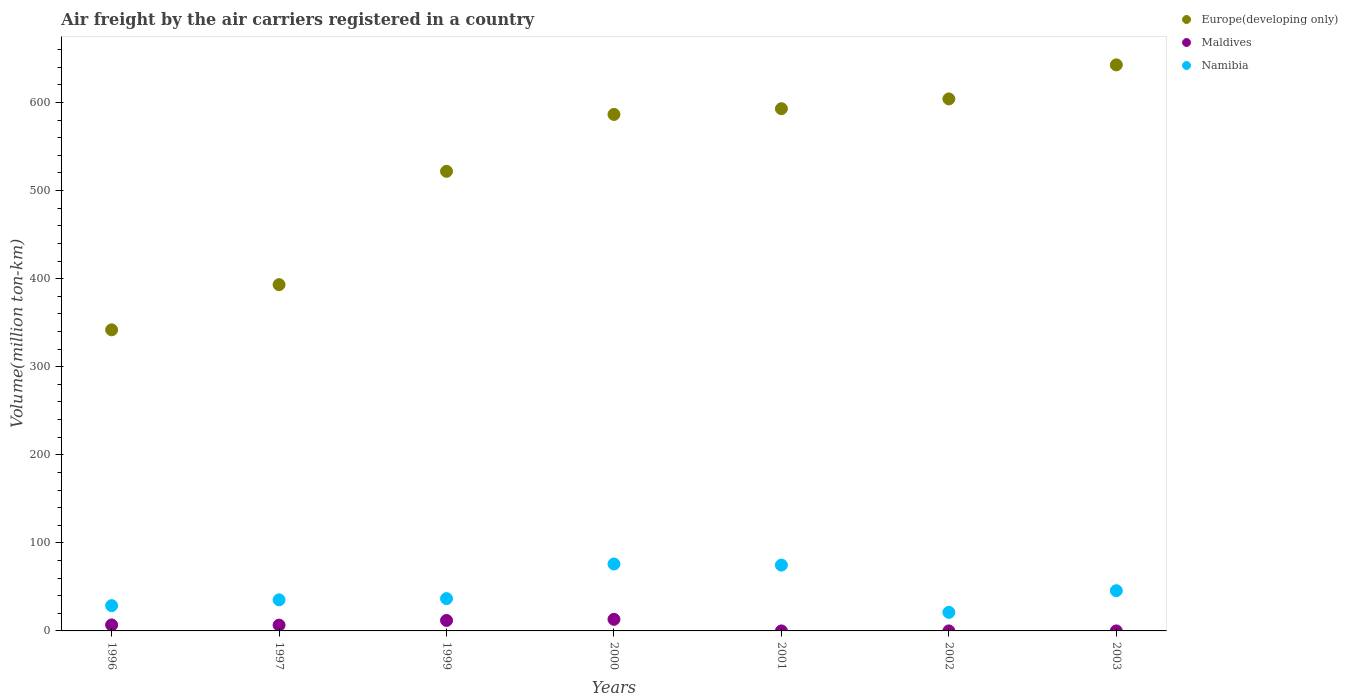How many different coloured dotlines are there?
Provide a short and direct response. 3. What is the volume of the air carriers in Namibia in 2000?
Offer a very short reply. 76.01. Across all years, what is the maximum volume of the air carriers in Maldives?
Your answer should be very brief. 13.17. Across all years, what is the minimum volume of the air carriers in Maldives?
Your answer should be compact. 0.01. What is the total volume of the air carriers in Namibia in the graph?
Ensure brevity in your answer.  318.19. What is the difference between the volume of the air carriers in Maldives in 2000 and that in 2002?
Provide a short and direct response. 13.16. What is the difference between the volume of the air carriers in Maldives in 2003 and the volume of the air carriers in Namibia in 1996?
Offer a very short reply. -28.69. What is the average volume of the air carriers in Namibia per year?
Give a very brief answer. 45.46. In the year 1999, what is the difference between the volume of the air carriers in Namibia and volume of the air carriers in Europe(developing only)?
Offer a terse response. -485.2. In how many years, is the volume of the air carriers in Maldives greater than 200 million ton-km?
Keep it short and to the point. 0. What is the ratio of the volume of the air carriers in Maldives in 1997 to that in 1999?
Your response must be concise. 0.55. What is the difference between the highest and the second highest volume of the air carriers in Namibia?
Ensure brevity in your answer.  1.26. What is the difference between the highest and the lowest volume of the air carriers in Maldives?
Keep it short and to the point. 13.16. In how many years, is the volume of the air carriers in Namibia greater than the average volume of the air carriers in Namibia taken over all years?
Offer a terse response. 3. Is the sum of the volume of the air carriers in Namibia in 2001 and 2002 greater than the maximum volume of the air carriers in Europe(developing only) across all years?
Your answer should be very brief. No. Is it the case that in every year, the sum of the volume of the air carriers in Europe(developing only) and volume of the air carriers in Maldives  is greater than the volume of the air carriers in Namibia?
Your response must be concise. Yes. Is the volume of the air carriers in Maldives strictly less than the volume of the air carriers in Europe(developing only) over the years?
Offer a terse response. Yes. How many years are there in the graph?
Ensure brevity in your answer.  7. Are the values on the major ticks of Y-axis written in scientific E-notation?
Your answer should be very brief. No. How are the legend labels stacked?
Your answer should be very brief. Vertical. What is the title of the graph?
Provide a short and direct response. Air freight by the air carriers registered in a country. Does "Estonia" appear as one of the legend labels in the graph?
Keep it short and to the point. No. What is the label or title of the X-axis?
Offer a terse response. Years. What is the label or title of the Y-axis?
Keep it short and to the point. Volume(million ton-km). What is the Volume(million ton-km) of Europe(developing only) in 1996?
Provide a succinct answer. 341.9. What is the Volume(million ton-km) of Maldives in 1996?
Offer a terse response. 6.8. What is the Volume(million ton-km) of Namibia in 1996?
Your answer should be very brief. 28.7. What is the Volume(million ton-km) of Europe(developing only) in 1997?
Give a very brief answer. 393.2. What is the Volume(million ton-km) of Maldives in 1997?
Keep it short and to the point. 6.6. What is the Volume(million ton-km) in Namibia in 1997?
Offer a very short reply. 35.3. What is the Volume(million ton-km) in Europe(developing only) in 1999?
Your answer should be compact. 521.9. What is the Volume(million ton-km) of Maldives in 1999?
Make the answer very short. 11.9. What is the Volume(million ton-km) of Namibia in 1999?
Make the answer very short. 36.7. What is the Volume(million ton-km) in Europe(developing only) in 2000?
Make the answer very short. 586.49. What is the Volume(million ton-km) in Maldives in 2000?
Provide a succinct answer. 13.17. What is the Volume(million ton-km) of Namibia in 2000?
Your answer should be very brief. 76.01. What is the Volume(million ton-km) in Europe(developing only) in 2001?
Ensure brevity in your answer.  593. What is the Volume(million ton-km) of Maldives in 2001?
Make the answer very short. 0.01. What is the Volume(million ton-km) in Namibia in 2001?
Offer a very short reply. 74.74. What is the Volume(million ton-km) of Europe(developing only) in 2002?
Make the answer very short. 604.13. What is the Volume(million ton-km) in Maldives in 2002?
Your answer should be compact. 0.01. What is the Volume(million ton-km) of Namibia in 2002?
Your answer should be compact. 21.06. What is the Volume(million ton-km) in Europe(developing only) in 2003?
Make the answer very short. 642.76. What is the Volume(million ton-km) in Maldives in 2003?
Your answer should be very brief. 0.01. What is the Volume(million ton-km) of Namibia in 2003?
Ensure brevity in your answer.  45.67. Across all years, what is the maximum Volume(million ton-km) of Europe(developing only)?
Give a very brief answer. 642.76. Across all years, what is the maximum Volume(million ton-km) in Maldives?
Your answer should be very brief. 13.17. Across all years, what is the maximum Volume(million ton-km) in Namibia?
Provide a succinct answer. 76.01. Across all years, what is the minimum Volume(million ton-km) in Europe(developing only)?
Ensure brevity in your answer.  341.9. Across all years, what is the minimum Volume(million ton-km) of Maldives?
Your response must be concise. 0.01. Across all years, what is the minimum Volume(million ton-km) in Namibia?
Offer a terse response. 21.06. What is the total Volume(million ton-km) in Europe(developing only) in the graph?
Your answer should be compact. 3683.38. What is the total Volume(million ton-km) in Maldives in the graph?
Offer a very short reply. 38.5. What is the total Volume(million ton-km) in Namibia in the graph?
Your answer should be compact. 318.19. What is the difference between the Volume(million ton-km) in Europe(developing only) in 1996 and that in 1997?
Your answer should be very brief. -51.3. What is the difference between the Volume(million ton-km) of Namibia in 1996 and that in 1997?
Provide a short and direct response. -6.6. What is the difference between the Volume(million ton-km) of Europe(developing only) in 1996 and that in 1999?
Make the answer very short. -180. What is the difference between the Volume(million ton-km) of Maldives in 1996 and that in 1999?
Your response must be concise. -5.1. What is the difference between the Volume(million ton-km) of Europe(developing only) in 1996 and that in 2000?
Provide a succinct answer. -244.59. What is the difference between the Volume(million ton-km) in Maldives in 1996 and that in 2000?
Provide a short and direct response. -6.37. What is the difference between the Volume(million ton-km) of Namibia in 1996 and that in 2000?
Ensure brevity in your answer.  -47.31. What is the difference between the Volume(million ton-km) of Europe(developing only) in 1996 and that in 2001?
Provide a succinct answer. -251.1. What is the difference between the Volume(million ton-km) in Maldives in 1996 and that in 2001?
Keep it short and to the point. 6.79. What is the difference between the Volume(million ton-km) in Namibia in 1996 and that in 2001?
Your answer should be very brief. -46.04. What is the difference between the Volume(million ton-km) of Europe(developing only) in 1996 and that in 2002?
Your answer should be very brief. -262.23. What is the difference between the Volume(million ton-km) in Maldives in 1996 and that in 2002?
Offer a very short reply. 6.79. What is the difference between the Volume(million ton-km) in Namibia in 1996 and that in 2002?
Your answer should be compact. 7.64. What is the difference between the Volume(million ton-km) in Europe(developing only) in 1996 and that in 2003?
Your response must be concise. -300.86. What is the difference between the Volume(million ton-km) in Maldives in 1996 and that in 2003?
Give a very brief answer. 6.79. What is the difference between the Volume(million ton-km) of Namibia in 1996 and that in 2003?
Your response must be concise. -16.98. What is the difference between the Volume(million ton-km) of Europe(developing only) in 1997 and that in 1999?
Your answer should be very brief. -128.7. What is the difference between the Volume(million ton-km) in Maldives in 1997 and that in 1999?
Your answer should be very brief. -5.3. What is the difference between the Volume(million ton-km) of Namibia in 1997 and that in 1999?
Offer a very short reply. -1.4. What is the difference between the Volume(million ton-km) of Europe(developing only) in 1997 and that in 2000?
Provide a succinct answer. -193.29. What is the difference between the Volume(million ton-km) in Maldives in 1997 and that in 2000?
Provide a short and direct response. -6.57. What is the difference between the Volume(million ton-km) of Namibia in 1997 and that in 2000?
Your answer should be very brief. -40.71. What is the difference between the Volume(million ton-km) of Europe(developing only) in 1997 and that in 2001?
Keep it short and to the point. -199.8. What is the difference between the Volume(million ton-km) in Maldives in 1997 and that in 2001?
Offer a very short reply. 6.59. What is the difference between the Volume(million ton-km) of Namibia in 1997 and that in 2001?
Your answer should be very brief. -39.44. What is the difference between the Volume(million ton-km) in Europe(developing only) in 1997 and that in 2002?
Offer a very short reply. -210.93. What is the difference between the Volume(million ton-km) in Maldives in 1997 and that in 2002?
Provide a short and direct response. 6.59. What is the difference between the Volume(million ton-km) of Namibia in 1997 and that in 2002?
Ensure brevity in your answer.  14.24. What is the difference between the Volume(million ton-km) in Europe(developing only) in 1997 and that in 2003?
Your answer should be compact. -249.56. What is the difference between the Volume(million ton-km) of Maldives in 1997 and that in 2003?
Provide a succinct answer. 6.59. What is the difference between the Volume(million ton-km) in Namibia in 1997 and that in 2003?
Make the answer very short. -10.38. What is the difference between the Volume(million ton-km) in Europe(developing only) in 1999 and that in 2000?
Your response must be concise. -64.59. What is the difference between the Volume(million ton-km) in Maldives in 1999 and that in 2000?
Ensure brevity in your answer.  -1.27. What is the difference between the Volume(million ton-km) of Namibia in 1999 and that in 2000?
Ensure brevity in your answer.  -39.31. What is the difference between the Volume(million ton-km) in Europe(developing only) in 1999 and that in 2001?
Your answer should be compact. -71.1. What is the difference between the Volume(million ton-km) in Maldives in 1999 and that in 2001?
Your response must be concise. 11.89. What is the difference between the Volume(million ton-km) in Namibia in 1999 and that in 2001?
Keep it short and to the point. -38.04. What is the difference between the Volume(million ton-km) of Europe(developing only) in 1999 and that in 2002?
Make the answer very short. -82.23. What is the difference between the Volume(million ton-km) of Maldives in 1999 and that in 2002?
Provide a short and direct response. 11.89. What is the difference between the Volume(million ton-km) of Namibia in 1999 and that in 2002?
Your answer should be compact. 15.64. What is the difference between the Volume(million ton-km) in Europe(developing only) in 1999 and that in 2003?
Your answer should be compact. -120.86. What is the difference between the Volume(million ton-km) of Maldives in 1999 and that in 2003?
Give a very brief answer. 11.89. What is the difference between the Volume(million ton-km) in Namibia in 1999 and that in 2003?
Your answer should be very brief. -8.97. What is the difference between the Volume(million ton-km) in Europe(developing only) in 2000 and that in 2001?
Make the answer very short. -6.51. What is the difference between the Volume(million ton-km) of Maldives in 2000 and that in 2001?
Make the answer very short. 13.16. What is the difference between the Volume(million ton-km) in Namibia in 2000 and that in 2001?
Provide a succinct answer. 1.26. What is the difference between the Volume(million ton-km) of Europe(developing only) in 2000 and that in 2002?
Provide a succinct answer. -17.64. What is the difference between the Volume(million ton-km) in Maldives in 2000 and that in 2002?
Keep it short and to the point. 13.16. What is the difference between the Volume(million ton-km) in Namibia in 2000 and that in 2002?
Give a very brief answer. 54.95. What is the difference between the Volume(million ton-km) in Europe(developing only) in 2000 and that in 2003?
Ensure brevity in your answer.  -56.27. What is the difference between the Volume(million ton-km) of Maldives in 2000 and that in 2003?
Your answer should be very brief. 13.16. What is the difference between the Volume(million ton-km) in Namibia in 2000 and that in 2003?
Keep it short and to the point. 30.33. What is the difference between the Volume(million ton-km) of Europe(developing only) in 2001 and that in 2002?
Give a very brief answer. -11.13. What is the difference between the Volume(million ton-km) in Maldives in 2001 and that in 2002?
Your response must be concise. -0. What is the difference between the Volume(million ton-km) in Namibia in 2001 and that in 2002?
Provide a succinct answer. 53.69. What is the difference between the Volume(million ton-km) of Europe(developing only) in 2001 and that in 2003?
Your response must be concise. -49.77. What is the difference between the Volume(million ton-km) in Maldives in 2001 and that in 2003?
Provide a succinct answer. -0. What is the difference between the Volume(million ton-km) in Namibia in 2001 and that in 2003?
Keep it short and to the point. 29.07. What is the difference between the Volume(million ton-km) of Europe(developing only) in 2002 and that in 2003?
Your answer should be very brief. -38.63. What is the difference between the Volume(million ton-km) in Namibia in 2002 and that in 2003?
Provide a succinct answer. -24.62. What is the difference between the Volume(million ton-km) in Europe(developing only) in 1996 and the Volume(million ton-km) in Maldives in 1997?
Offer a terse response. 335.3. What is the difference between the Volume(million ton-km) in Europe(developing only) in 1996 and the Volume(million ton-km) in Namibia in 1997?
Keep it short and to the point. 306.6. What is the difference between the Volume(million ton-km) of Maldives in 1996 and the Volume(million ton-km) of Namibia in 1997?
Ensure brevity in your answer.  -28.5. What is the difference between the Volume(million ton-km) in Europe(developing only) in 1996 and the Volume(million ton-km) in Maldives in 1999?
Offer a very short reply. 330. What is the difference between the Volume(million ton-km) in Europe(developing only) in 1996 and the Volume(million ton-km) in Namibia in 1999?
Offer a terse response. 305.2. What is the difference between the Volume(million ton-km) in Maldives in 1996 and the Volume(million ton-km) in Namibia in 1999?
Ensure brevity in your answer.  -29.9. What is the difference between the Volume(million ton-km) of Europe(developing only) in 1996 and the Volume(million ton-km) of Maldives in 2000?
Provide a succinct answer. 328.73. What is the difference between the Volume(million ton-km) of Europe(developing only) in 1996 and the Volume(million ton-km) of Namibia in 2000?
Provide a succinct answer. 265.89. What is the difference between the Volume(million ton-km) in Maldives in 1996 and the Volume(million ton-km) in Namibia in 2000?
Make the answer very short. -69.21. What is the difference between the Volume(million ton-km) in Europe(developing only) in 1996 and the Volume(million ton-km) in Maldives in 2001?
Provide a short and direct response. 341.89. What is the difference between the Volume(million ton-km) in Europe(developing only) in 1996 and the Volume(million ton-km) in Namibia in 2001?
Offer a terse response. 267.16. What is the difference between the Volume(million ton-km) in Maldives in 1996 and the Volume(million ton-km) in Namibia in 2001?
Provide a succinct answer. -67.94. What is the difference between the Volume(million ton-km) of Europe(developing only) in 1996 and the Volume(million ton-km) of Maldives in 2002?
Give a very brief answer. 341.89. What is the difference between the Volume(million ton-km) in Europe(developing only) in 1996 and the Volume(million ton-km) in Namibia in 2002?
Offer a very short reply. 320.84. What is the difference between the Volume(million ton-km) in Maldives in 1996 and the Volume(million ton-km) in Namibia in 2002?
Make the answer very short. -14.26. What is the difference between the Volume(million ton-km) in Europe(developing only) in 1996 and the Volume(million ton-km) in Maldives in 2003?
Keep it short and to the point. 341.89. What is the difference between the Volume(million ton-km) of Europe(developing only) in 1996 and the Volume(million ton-km) of Namibia in 2003?
Provide a succinct answer. 296.23. What is the difference between the Volume(million ton-km) in Maldives in 1996 and the Volume(million ton-km) in Namibia in 2003?
Keep it short and to the point. -38.88. What is the difference between the Volume(million ton-km) of Europe(developing only) in 1997 and the Volume(million ton-km) of Maldives in 1999?
Offer a very short reply. 381.3. What is the difference between the Volume(million ton-km) of Europe(developing only) in 1997 and the Volume(million ton-km) of Namibia in 1999?
Your answer should be very brief. 356.5. What is the difference between the Volume(million ton-km) of Maldives in 1997 and the Volume(million ton-km) of Namibia in 1999?
Provide a succinct answer. -30.1. What is the difference between the Volume(million ton-km) in Europe(developing only) in 1997 and the Volume(million ton-km) in Maldives in 2000?
Ensure brevity in your answer.  380.03. What is the difference between the Volume(million ton-km) of Europe(developing only) in 1997 and the Volume(million ton-km) of Namibia in 2000?
Give a very brief answer. 317.19. What is the difference between the Volume(million ton-km) in Maldives in 1997 and the Volume(million ton-km) in Namibia in 2000?
Your answer should be compact. -69.41. What is the difference between the Volume(million ton-km) of Europe(developing only) in 1997 and the Volume(million ton-km) of Maldives in 2001?
Provide a short and direct response. 393.19. What is the difference between the Volume(million ton-km) in Europe(developing only) in 1997 and the Volume(million ton-km) in Namibia in 2001?
Your answer should be compact. 318.46. What is the difference between the Volume(million ton-km) of Maldives in 1997 and the Volume(million ton-km) of Namibia in 2001?
Provide a short and direct response. -68.14. What is the difference between the Volume(million ton-km) in Europe(developing only) in 1997 and the Volume(million ton-km) in Maldives in 2002?
Offer a terse response. 393.19. What is the difference between the Volume(million ton-km) in Europe(developing only) in 1997 and the Volume(million ton-km) in Namibia in 2002?
Give a very brief answer. 372.14. What is the difference between the Volume(million ton-km) in Maldives in 1997 and the Volume(million ton-km) in Namibia in 2002?
Give a very brief answer. -14.46. What is the difference between the Volume(million ton-km) of Europe(developing only) in 1997 and the Volume(million ton-km) of Maldives in 2003?
Offer a terse response. 393.19. What is the difference between the Volume(million ton-km) of Europe(developing only) in 1997 and the Volume(million ton-km) of Namibia in 2003?
Your response must be concise. 347.52. What is the difference between the Volume(million ton-km) in Maldives in 1997 and the Volume(million ton-km) in Namibia in 2003?
Your answer should be compact. -39.08. What is the difference between the Volume(million ton-km) of Europe(developing only) in 1999 and the Volume(million ton-km) of Maldives in 2000?
Give a very brief answer. 508.73. What is the difference between the Volume(million ton-km) in Europe(developing only) in 1999 and the Volume(million ton-km) in Namibia in 2000?
Ensure brevity in your answer.  445.89. What is the difference between the Volume(million ton-km) of Maldives in 1999 and the Volume(million ton-km) of Namibia in 2000?
Ensure brevity in your answer.  -64.11. What is the difference between the Volume(million ton-km) of Europe(developing only) in 1999 and the Volume(million ton-km) of Maldives in 2001?
Your answer should be very brief. 521.89. What is the difference between the Volume(million ton-km) of Europe(developing only) in 1999 and the Volume(million ton-km) of Namibia in 2001?
Offer a terse response. 447.16. What is the difference between the Volume(million ton-km) in Maldives in 1999 and the Volume(million ton-km) in Namibia in 2001?
Keep it short and to the point. -62.84. What is the difference between the Volume(million ton-km) in Europe(developing only) in 1999 and the Volume(million ton-km) in Maldives in 2002?
Offer a very short reply. 521.89. What is the difference between the Volume(million ton-km) of Europe(developing only) in 1999 and the Volume(million ton-km) of Namibia in 2002?
Ensure brevity in your answer.  500.84. What is the difference between the Volume(million ton-km) in Maldives in 1999 and the Volume(million ton-km) in Namibia in 2002?
Keep it short and to the point. -9.16. What is the difference between the Volume(million ton-km) in Europe(developing only) in 1999 and the Volume(million ton-km) in Maldives in 2003?
Provide a short and direct response. 521.89. What is the difference between the Volume(million ton-km) in Europe(developing only) in 1999 and the Volume(million ton-km) in Namibia in 2003?
Your answer should be very brief. 476.23. What is the difference between the Volume(million ton-km) in Maldives in 1999 and the Volume(million ton-km) in Namibia in 2003?
Provide a succinct answer. -33.77. What is the difference between the Volume(million ton-km) in Europe(developing only) in 2000 and the Volume(million ton-km) in Maldives in 2001?
Provide a succinct answer. 586.48. What is the difference between the Volume(million ton-km) in Europe(developing only) in 2000 and the Volume(million ton-km) in Namibia in 2001?
Keep it short and to the point. 511.75. What is the difference between the Volume(million ton-km) in Maldives in 2000 and the Volume(million ton-km) in Namibia in 2001?
Your answer should be very brief. -61.57. What is the difference between the Volume(million ton-km) in Europe(developing only) in 2000 and the Volume(million ton-km) in Maldives in 2002?
Ensure brevity in your answer.  586.48. What is the difference between the Volume(million ton-km) in Europe(developing only) in 2000 and the Volume(million ton-km) in Namibia in 2002?
Provide a succinct answer. 565.43. What is the difference between the Volume(million ton-km) of Maldives in 2000 and the Volume(million ton-km) of Namibia in 2002?
Provide a succinct answer. -7.89. What is the difference between the Volume(million ton-km) of Europe(developing only) in 2000 and the Volume(million ton-km) of Maldives in 2003?
Provide a short and direct response. 586.48. What is the difference between the Volume(million ton-km) in Europe(developing only) in 2000 and the Volume(million ton-km) in Namibia in 2003?
Make the answer very short. 540.82. What is the difference between the Volume(million ton-km) of Maldives in 2000 and the Volume(million ton-km) of Namibia in 2003?
Offer a very short reply. -32.51. What is the difference between the Volume(million ton-km) of Europe(developing only) in 2001 and the Volume(million ton-km) of Maldives in 2002?
Provide a short and direct response. 592.99. What is the difference between the Volume(million ton-km) in Europe(developing only) in 2001 and the Volume(million ton-km) in Namibia in 2002?
Your response must be concise. 571.94. What is the difference between the Volume(million ton-km) in Maldives in 2001 and the Volume(million ton-km) in Namibia in 2002?
Offer a very short reply. -21.05. What is the difference between the Volume(million ton-km) of Europe(developing only) in 2001 and the Volume(million ton-km) of Maldives in 2003?
Your answer should be compact. 592.99. What is the difference between the Volume(million ton-km) in Europe(developing only) in 2001 and the Volume(million ton-km) in Namibia in 2003?
Give a very brief answer. 547.32. What is the difference between the Volume(million ton-km) of Maldives in 2001 and the Volume(million ton-km) of Namibia in 2003?
Make the answer very short. -45.67. What is the difference between the Volume(million ton-km) of Europe(developing only) in 2002 and the Volume(million ton-km) of Maldives in 2003?
Ensure brevity in your answer.  604.12. What is the difference between the Volume(million ton-km) of Europe(developing only) in 2002 and the Volume(million ton-km) of Namibia in 2003?
Keep it short and to the point. 558.45. What is the difference between the Volume(million ton-km) in Maldives in 2002 and the Volume(million ton-km) in Namibia in 2003?
Offer a very short reply. -45.67. What is the average Volume(million ton-km) in Europe(developing only) per year?
Your response must be concise. 526.2. What is the average Volume(million ton-km) of Maldives per year?
Your answer should be compact. 5.5. What is the average Volume(million ton-km) of Namibia per year?
Provide a short and direct response. 45.45. In the year 1996, what is the difference between the Volume(million ton-km) of Europe(developing only) and Volume(million ton-km) of Maldives?
Offer a very short reply. 335.1. In the year 1996, what is the difference between the Volume(million ton-km) of Europe(developing only) and Volume(million ton-km) of Namibia?
Offer a very short reply. 313.2. In the year 1996, what is the difference between the Volume(million ton-km) of Maldives and Volume(million ton-km) of Namibia?
Give a very brief answer. -21.9. In the year 1997, what is the difference between the Volume(million ton-km) of Europe(developing only) and Volume(million ton-km) of Maldives?
Offer a terse response. 386.6. In the year 1997, what is the difference between the Volume(million ton-km) of Europe(developing only) and Volume(million ton-km) of Namibia?
Offer a terse response. 357.9. In the year 1997, what is the difference between the Volume(million ton-km) of Maldives and Volume(million ton-km) of Namibia?
Provide a succinct answer. -28.7. In the year 1999, what is the difference between the Volume(million ton-km) in Europe(developing only) and Volume(million ton-km) in Maldives?
Make the answer very short. 510. In the year 1999, what is the difference between the Volume(million ton-km) of Europe(developing only) and Volume(million ton-km) of Namibia?
Offer a very short reply. 485.2. In the year 1999, what is the difference between the Volume(million ton-km) in Maldives and Volume(million ton-km) in Namibia?
Provide a short and direct response. -24.8. In the year 2000, what is the difference between the Volume(million ton-km) of Europe(developing only) and Volume(million ton-km) of Maldives?
Offer a very short reply. 573.32. In the year 2000, what is the difference between the Volume(million ton-km) of Europe(developing only) and Volume(million ton-km) of Namibia?
Provide a succinct answer. 510.48. In the year 2000, what is the difference between the Volume(million ton-km) in Maldives and Volume(million ton-km) in Namibia?
Provide a succinct answer. -62.84. In the year 2001, what is the difference between the Volume(million ton-km) of Europe(developing only) and Volume(million ton-km) of Maldives?
Offer a very short reply. 592.99. In the year 2001, what is the difference between the Volume(million ton-km) in Europe(developing only) and Volume(million ton-km) in Namibia?
Ensure brevity in your answer.  518.25. In the year 2001, what is the difference between the Volume(million ton-km) of Maldives and Volume(million ton-km) of Namibia?
Your response must be concise. -74.74. In the year 2002, what is the difference between the Volume(million ton-km) in Europe(developing only) and Volume(million ton-km) in Maldives?
Provide a short and direct response. 604.12. In the year 2002, what is the difference between the Volume(million ton-km) in Europe(developing only) and Volume(million ton-km) in Namibia?
Provide a succinct answer. 583.07. In the year 2002, what is the difference between the Volume(million ton-km) in Maldives and Volume(million ton-km) in Namibia?
Give a very brief answer. -21.05. In the year 2003, what is the difference between the Volume(million ton-km) of Europe(developing only) and Volume(million ton-km) of Maldives?
Your answer should be compact. 642.75. In the year 2003, what is the difference between the Volume(million ton-km) in Europe(developing only) and Volume(million ton-km) in Namibia?
Your answer should be compact. 597.09. In the year 2003, what is the difference between the Volume(million ton-km) in Maldives and Volume(million ton-km) in Namibia?
Offer a terse response. -45.67. What is the ratio of the Volume(million ton-km) of Europe(developing only) in 1996 to that in 1997?
Your answer should be compact. 0.87. What is the ratio of the Volume(million ton-km) in Maldives in 1996 to that in 1997?
Keep it short and to the point. 1.03. What is the ratio of the Volume(million ton-km) in Namibia in 1996 to that in 1997?
Ensure brevity in your answer.  0.81. What is the ratio of the Volume(million ton-km) in Europe(developing only) in 1996 to that in 1999?
Your answer should be compact. 0.66. What is the ratio of the Volume(million ton-km) of Namibia in 1996 to that in 1999?
Make the answer very short. 0.78. What is the ratio of the Volume(million ton-km) of Europe(developing only) in 1996 to that in 2000?
Your answer should be very brief. 0.58. What is the ratio of the Volume(million ton-km) of Maldives in 1996 to that in 2000?
Your response must be concise. 0.52. What is the ratio of the Volume(million ton-km) of Namibia in 1996 to that in 2000?
Offer a terse response. 0.38. What is the ratio of the Volume(million ton-km) of Europe(developing only) in 1996 to that in 2001?
Keep it short and to the point. 0.58. What is the ratio of the Volume(million ton-km) in Maldives in 1996 to that in 2001?
Your response must be concise. 850. What is the ratio of the Volume(million ton-km) of Namibia in 1996 to that in 2001?
Provide a short and direct response. 0.38. What is the ratio of the Volume(million ton-km) in Europe(developing only) in 1996 to that in 2002?
Keep it short and to the point. 0.57. What is the ratio of the Volume(million ton-km) in Maldives in 1996 to that in 2002?
Your answer should be compact. 755.56. What is the ratio of the Volume(million ton-km) of Namibia in 1996 to that in 2002?
Keep it short and to the point. 1.36. What is the ratio of the Volume(million ton-km) of Europe(developing only) in 1996 to that in 2003?
Provide a succinct answer. 0.53. What is the ratio of the Volume(million ton-km) in Maldives in 1996 to that in 2003?
Provide a succinct answer. 755.56. What is the ratio of the Volume(million ton-km) of Namibia in 1996 to that in 2003?
Provide a short and direct response. 0.63. What is the ratio of the Volume(million ton-km) in Europe(developing only) in 1997 to that in 1999?
Offer a very short reply. 0.75. What is the ratio of the Volume(million ton-km) in Maldives in 1997 to that in 1999?
Your answer should be compact. 0.55. What is the ratio of the Volume(million ton-km) of Namibia in 1997 to that in 1999?
Make the answer very short. 0.96. What is the ratio of the Volume(million ton-km) in Europe(developing only) in 1997 to that in 2000?
Provide a short and direct response. 0.67. What is the ratio of the Volume(million ton-km) in Maldives in 1997 to that in 2000?
Provide a succinct answer. 0.5. What is the ratio of the Volume(million ton-km) in Namibia in 1997 to that in 2000?
Your response must be concise. 0.46. What is the ratio of the Volume(million ton-km) of Europe(developing only) in 1997 to that in 2001?
Your answer should be very brief. 0.66. What is the ratio of the Volume(million ton-km) in Maldives in 1997 to that in 2001?
Your response must be concise. 825. What is the ratio of the Volume(million ton-km) in Namibia in 1997 to that in 2001?
Offer a very short reply. 0.47. What is the ratio of the Volume(million ton-km) of Europe(developing only) in 1997 to that in 2002?
Ensure brevity in your answer.  0.65. What is the ratio of the Volume(million ton-km) in Maldives in 1997 to that in 2002?
Your response must be concise. 733.33. What is the ratio of the Volume(million ton-km) of Namibia in 1997 to that in 2002?
Provide a succinct answer. 1.68. What is the ratio of the Volume(million ton-km) in Europe(developing only) in 1997 to that in 2003?
Keep it short and to the point. 0.61. What is the ratio of the Volume(million ton-km) of Maldives in 1997 to that in 2003?
Your answer should be compact. 733.33. What is the ratio of the Volume(million ton-km) in Namibia in 1997 to that in 2003?
Offer a terse response. 0.77. What is the ratio of the Volume(million ton-km) in Europe(developing only) in 1999 to that in 2000?
Give a very brief answer. 0.89. What is the ratio of the Volume(million ton-km) in Maldives in 1999 to that in 2000?
Your response must be concise. 0.9. What is the ratio of the Volume(million ton-km) of Namibia in 1999 to that in 2000?
Provide a short and direct response. 0.48. What is the ratio of the Volume(million ton-km) in Europe(developing only) in 1999 to that in 2001?
Give a very brief answer. 0.88. What is the ratio of the Volume(million ton-km) in Maldives in 1999 to that in 2001?
Provide a succinct answer. 1487.5. What is the ratio of the Volume(million ton-km) of Namibia in 1999 to that in 2001?
Your answer should be very brief. 0.49. What is the ratio of the Volume(million ton-km) of Europe(developing only) in 1999 to that in 2002?
Provide a short and direct response. 0.86. What is the ratio of the Volume(million ton-km) in Maldives in 1999 to that in 2002?
Make the answer very short. 1322.22. What is the ratio of the Volume(million ton-km) in Namibia in 1999 to that in 2002?
Keep it short and to the point. 1.74. What is the ratio of the Volume(million ton-km) in Europe(developing only) in 1999 to that in 2003?
Provide a short and direct response. 0.81. What is the ratio of the Volume(million ton-km) in Maldives in 1999 to that in 2003?
Your response must be concise. 1322.22. What is the ratio of the Volume(million ton-km) in Namibia in 1999 to that in 2003?
Your answer should be compact. 0.8. What is the ratio of the Volume(million ton-km) in Maldives in 2000 to that in 2001?
Ensure brevity in your answer.  1646.25. What is the ratio of the Volume(million ton-km) of Namibia in 2000 to that in 2001?
Offer a terse response. 1.02. What is the ratio of the Volume(million ton-km) of Europe(developing only) in 2000 to that in 2002?
Your answer should be very brief. 0.97. What is the ratio of the Volume(million ton-km) in Maldives in 2000 to that in 2002?
Offer a very short reply. 1463.33. What is the ratio of the Volume(million ton-km) of Namibia in 2000 to that in 2002?
Offer a terse response. 3.61. What is the ratio of the Volume(million ton-km) in Europe(developing only) in 2000 to that in 2003?
Your answer should be very brief. 0.91. What is the ratio of the Volume(million ton-km) of Maldives in 2000 to that in 2003?
Ensure brevity in your answer.  1463.33. What is the ratio of the Volume(million ton-km) of Namibia in 2000 to that in 2003?
Your answer should be compact. 1.66. What is the ratio of the Volume(million ton-km) of Europe(developing only) in 2001 to that in 2002?
Your response must be concise. 0.98. What is the ratio of the Volume(million ton-km) in Maldives in 2001 to that in 2002?
Give a very brief answer. 0.89. What is the ratio of the Volume(million ton-km) of Namibia in 2001 to that in 2002?
Provide a succinct answer. 3.55. What is the ratio of the Volume(million ton-km) of Europe(developing only) in 2001 to that in 2003?
Keep it short and to the point. 0.92. What is the ratio of the Volume(million ton-km) in Maldives in 2001 to that in 2003?
Your answer should be very brief. 0.89. What is the ratio of the Volume(million ton-km) of Namibia in 2001 to that in 2003?
Ensure brevity in your answer.  1.64. What is the ratio of the Volume(million ton-km) of Europe(developing only) in 2002 to that in 2003?
Your answer should be very brief. 0.94. What is the ratio of the Volume(million ton-km) of Maldives in 2002 to that in 2003?
Make the answer very short. 1. What is the ratio of the Volume(million ton-km) in Namibia in 2002 to that in 2003?
Offer a terse response. 0.46. What is the difference between the highest and the second highest Volume(million ton-km) in Europe(developing only)?
Your answer should be very brief. 38.63. What is the difference between the highest and the second highest Volume(million ton-km) in Maldives?
Provide a succinct answer. 1.27. What is the difference between the highest and the second highest Volume(million ton-km) in Namibia?
Ensure brevity in your answer.  1.26. What is the difference between the highest and the lowest Volume(million ton-km) of Europe(developing only)?
Your answer should be compact. 300.86. What is the difference between the highest and the lowest Volume(million ton-km) of Maldives?
Keep it short and to the point. 13.16. What is the difference between the highest and the lowest Volume(million ton-km) of Namibia?
Offer a terse response. 54.95. 